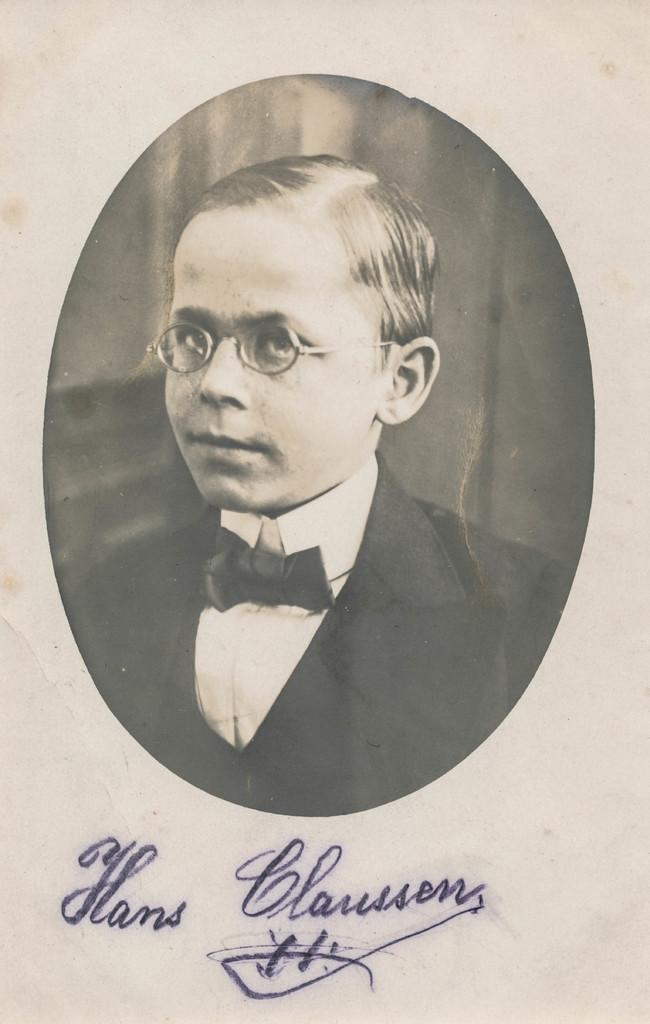What is present in the image that contains a photograph? There is a paper in the image that contains a photograph. What can be seen in the photograph on the paper? The photograph on the paper is of a boy. How is the boy in the photograph dressed? The boy in the photograph is wearing a blazer and tie. Is there any writing or markings under the photograph? Yes, there is a signature under the photograph. What type of disease is affecting the boy in the photograph? There is no indication of any disease affecting the boy in the photograph; the image only shows a photograph of a boy wearing a blazer and tie. 